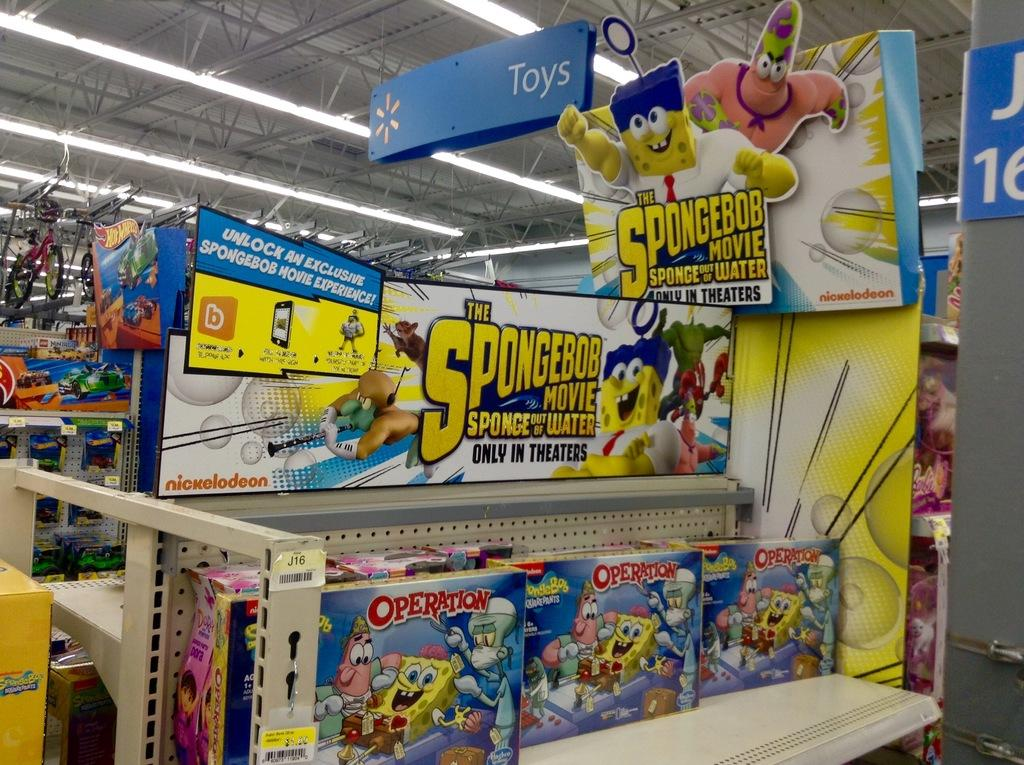<image>
Give a short and clear explanation of the subsequent image. the spongebob movie has a game of operation tha t is being sold here 